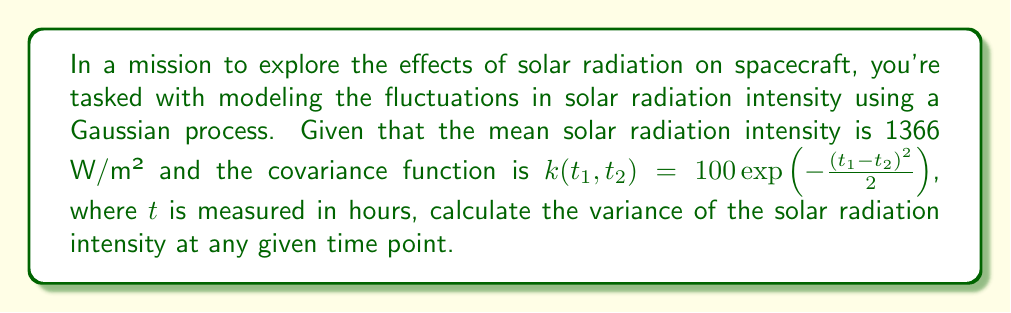Provide a solution to this math problem. To solve this problem, we'll follow these steps:

1) In a Gaussian process, the variance at a single time point is given by the covariance function when both time inputs are the same, i.e., $k(t, t)$.

2) Our covariance function is:

   $$k(t_1, t_2) = 100 \exp(-\frac{(t_1 - t_2)^2}{2})$$

3) To find the variance, we set $t_1 = t_2 = t$:

   $$k(t, t) = 100 \exp(-\frac{(t - t)^2}{2})$$

4) Simplify:
   
   $$k(t, t) = 100 \exp(-\frac{0^2}{2}) = 100 \exp(0) = 100$$

5) Therefore, the variance of the solar radiation intensity at any given time point is 100 (W/m²)².

Note: The mean solar radiation intensity (1366 W/m²) is not used in this calculation, as we're only asked for the variance. In a Gaussian process, the mean and covariance functions are independent.
Answer: 100 (W/m²)² 